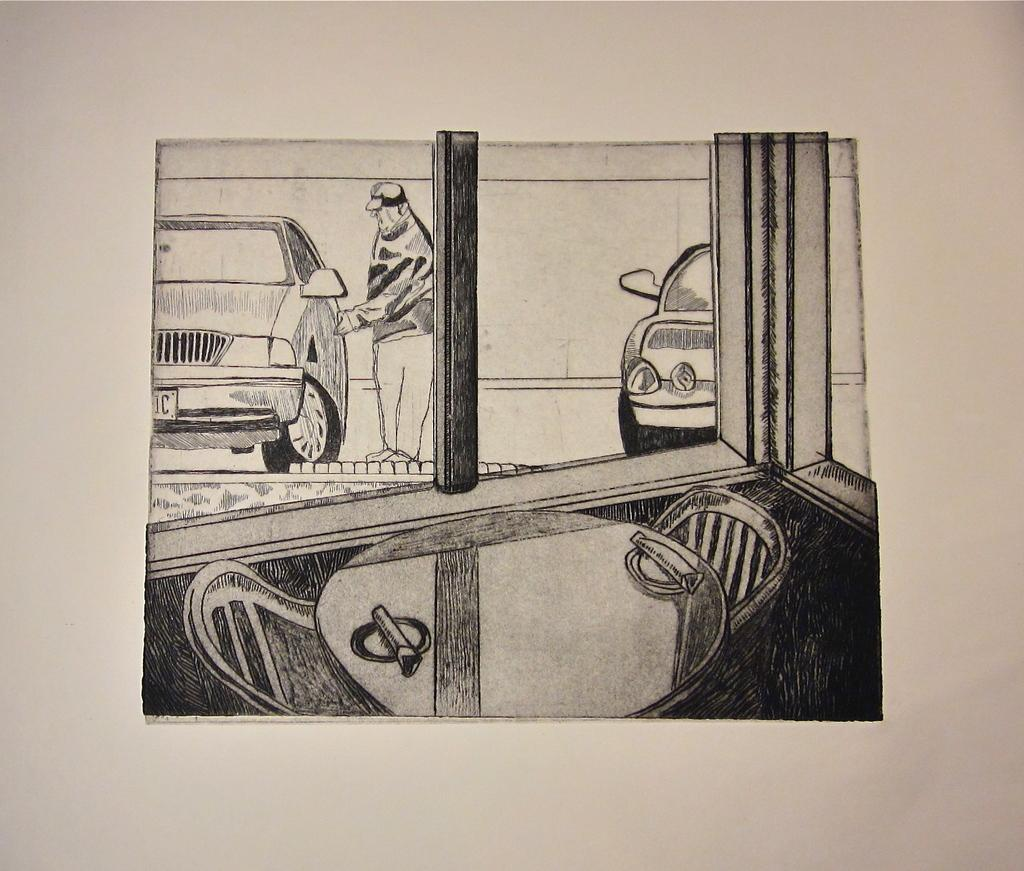What is the main subject in the center of the image? There is a drawing in the center of the image. What can be seen in the background of the image? There is a person, cars, a window, a table, and chairs in the background of the image. What type of board is being used to cut the celery in the image? There is no board or celery present in the image. 